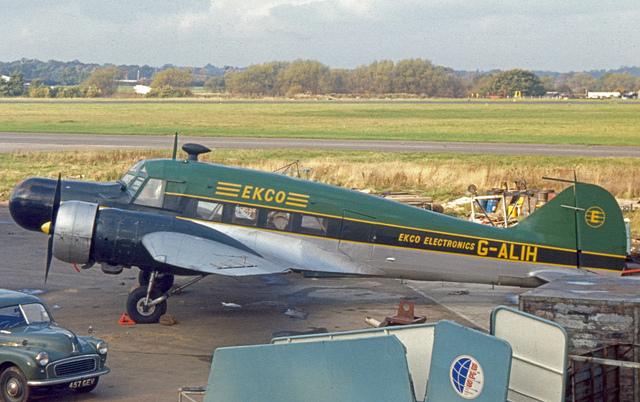Is that a commercial plane?
Quick response, please. No. What kind of plane is this according to the writing on it?
Be succinct. Ekco. What model is the car?
Answer briefly. Ford. 